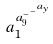<formula> <loc_0><loc_0><loc_500><loc_500>a _ { 1 } ^ { a _ { 9 } ^ { - ^ { - ^ { a _ { y } } } } }</formula> 